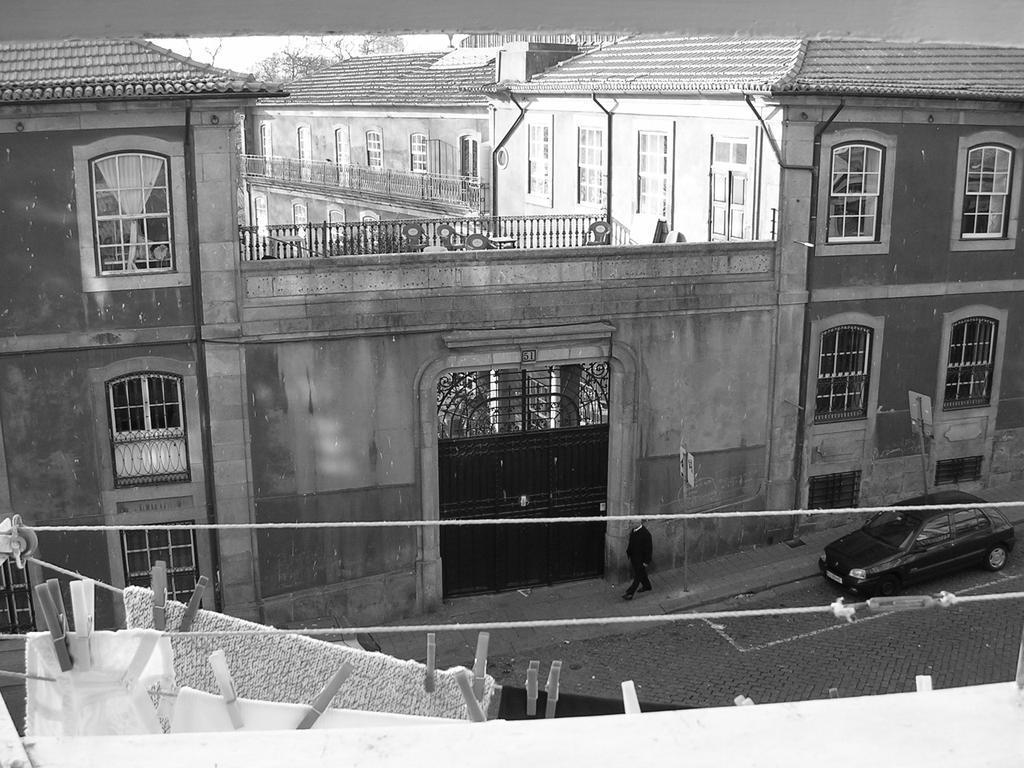In one or two sentences, can you explain what this image depicts? It is a black and white image and there is a huge building, in front of the building there is a man and behind the man there is a car parked beside the building, in the front there are some clothes hanged on a rope. 